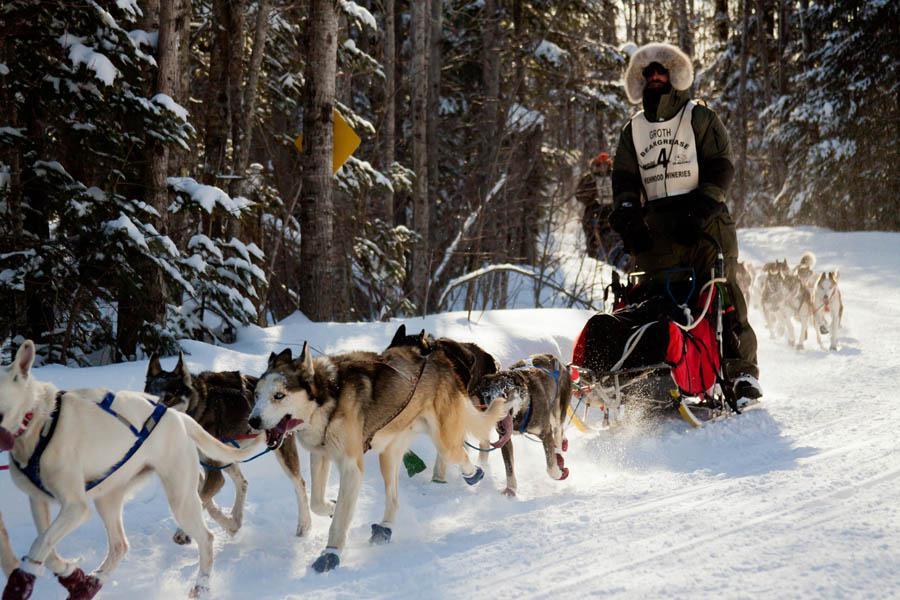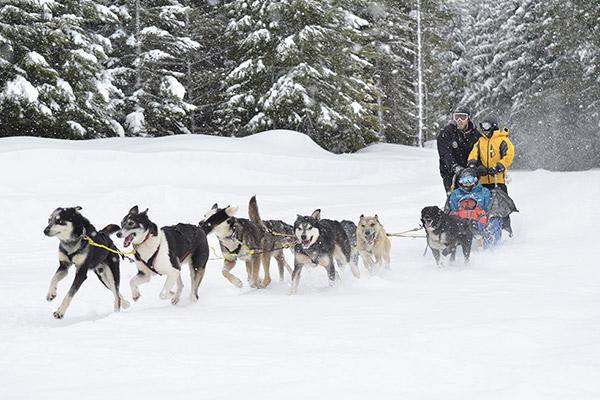The first image is the image on the left, the second image is the image on the right. For the images shown, is this caption "The person in the sled in the image on the left is wearing a white numbered vest." true? Answer yes or no. Yes. The first image is the image on the left, the second image is the image on the right. Considering the images on both sides, is "One of the sleds is pulled by no more than 3 dogs." valid? Answer yes or no. No. 